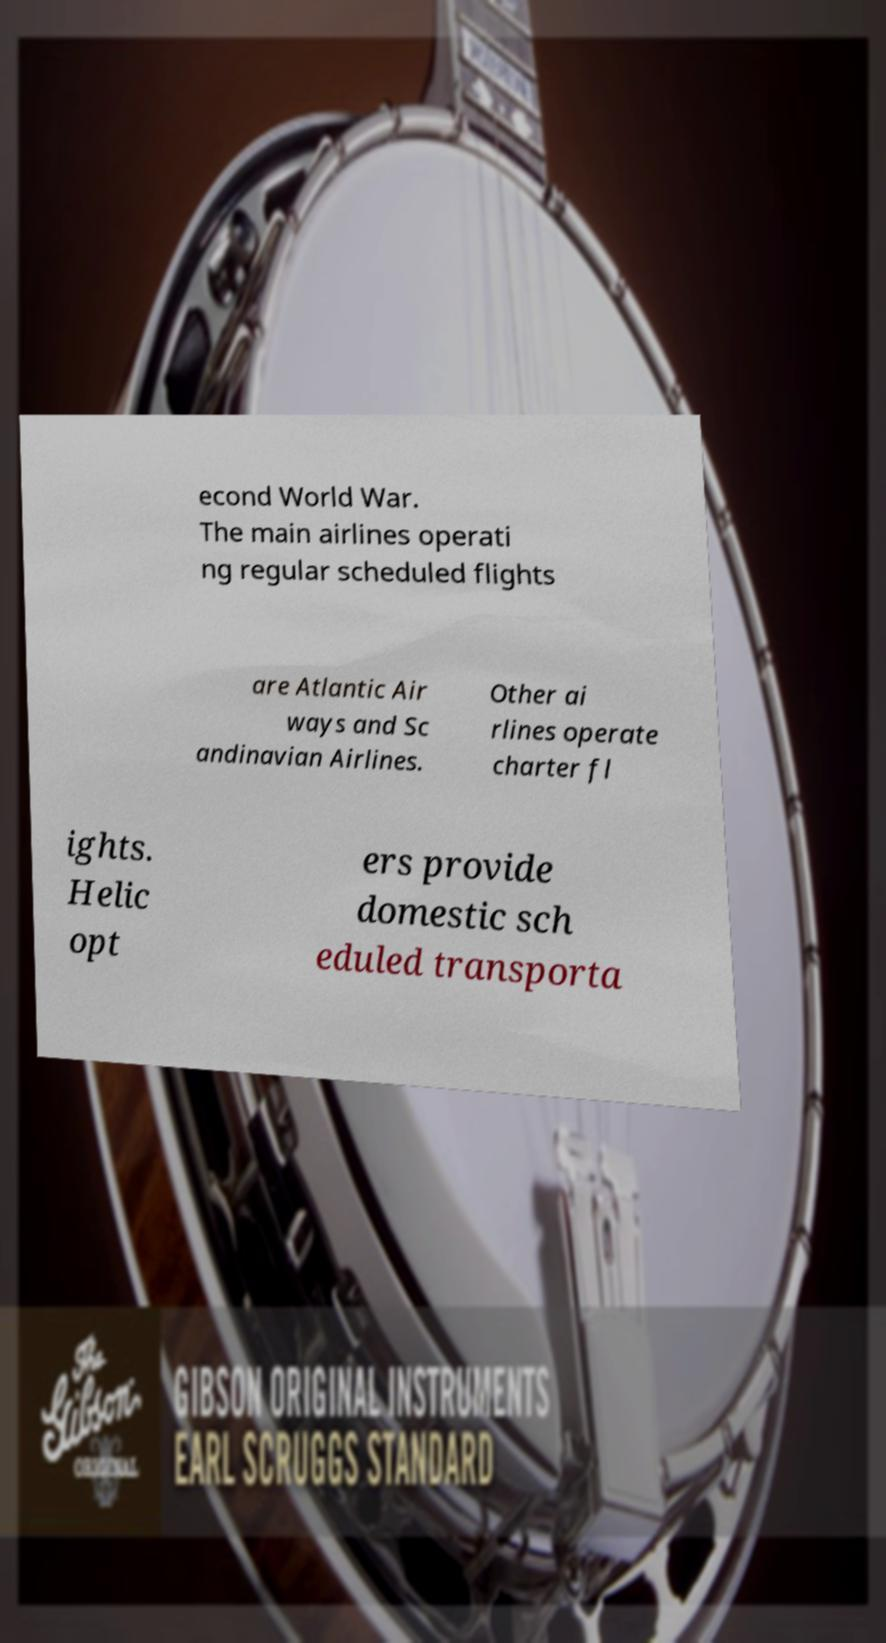Can you read and provide the text displayed in the image?This photo seems to have some interesting text. Can you extract and type it out for me? econd World War. The main airlines operati ng regular scheduled flights are Atlantic Air ways and Sc andinavian Airlines. Other ai rlines operate charter fl ights. Helic opt ers provide domestic sch eduled transporta 